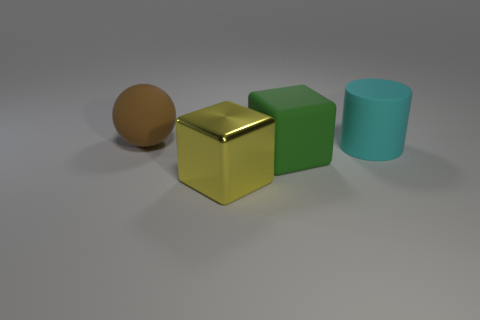There is another large object that is the same shape as the large green matte thing; what color is it?
Keep it short and to the point. Yellow. Is there any other thing that is the same shape as the large brown thing?
Offer a very short reply. No. Are there more yellow metal objects that are on the right side of the large sphere than big brown things that are on the right side of the metal thing?
Provide a short and direct response. Yes. How big is the matte cylinder that is right of the cube on the right side of the cube that is left of the rubber cube?
Provide a short and direct response. Large. Is the material of the large green thing the same as the large thing right of the green matte block?
Offer a terse response. Yes. Do the metallic object and the brown matte thing have the same shape?
Your answer should be very brief. No. How many other things are there of the same material as the sphere?
Offer a terse response. 2. How many other objects have the same shape as the brown rubber object?
Your response must be concise. 0. The big matte object that is both left of the large cyan rubber cylinder and on the right side of the brown matte thing is what color?
Your answer should be compact. Green. What number of red matte blocks are there?
Your answer should be compact. 0. 